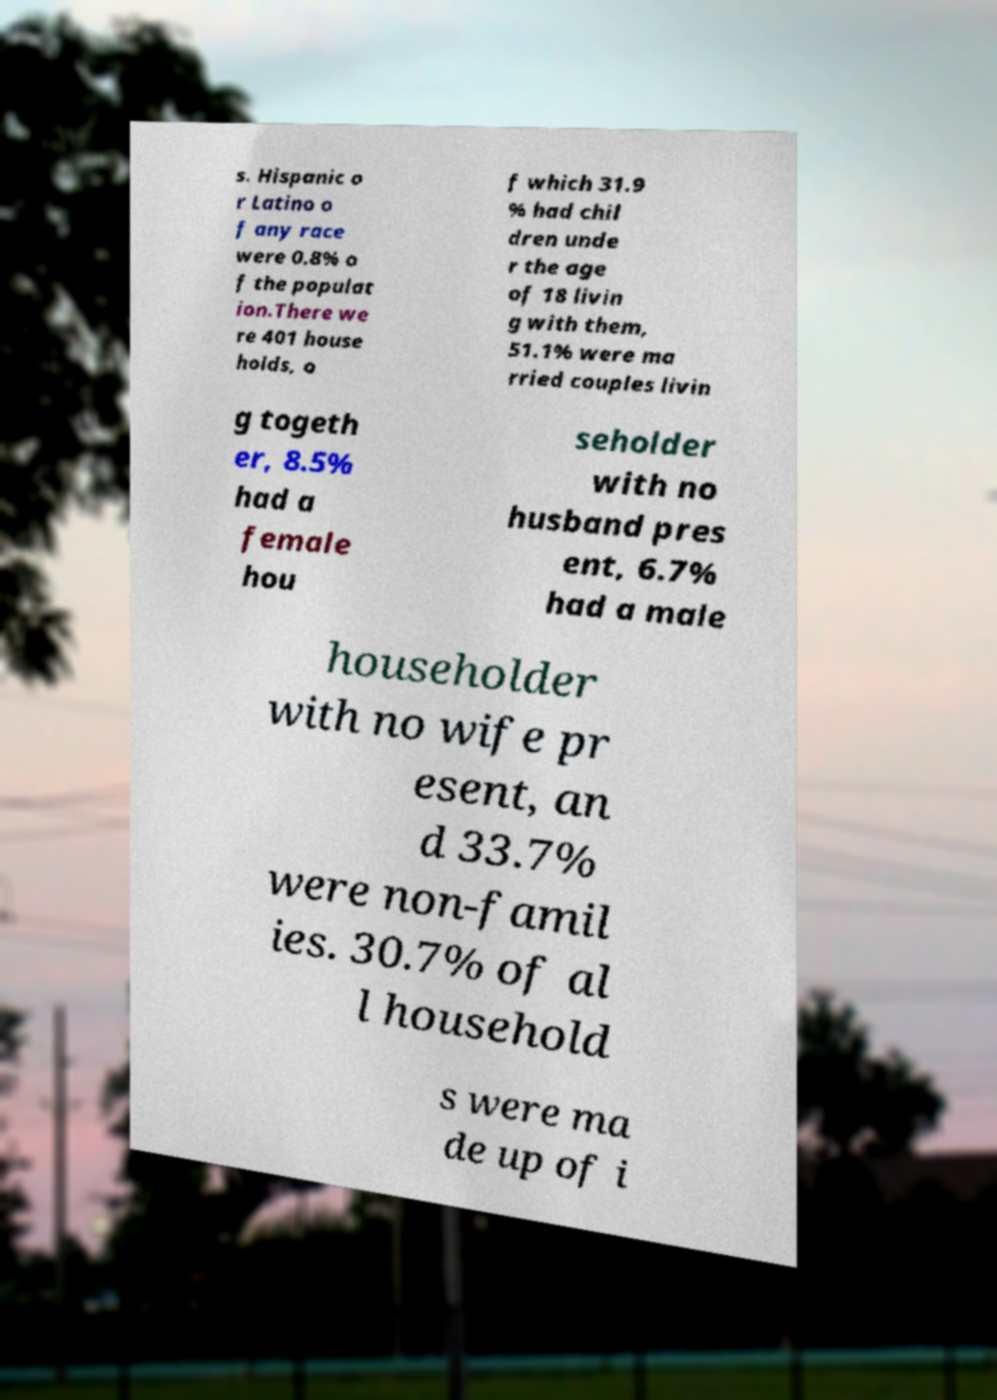What messages or text are displayed in this image? I need them in a readable, typed format. s. Hispanic o r Latino o f any race were 0.8% o f the populat ion.There we re 401 house holds, o f which 31.9 % had chil dren unde r the age of 18 livin g with them, 51.1% were ma rried couples livin g togeth er, 8.5% had a female hou seholder with no husband pres ent, 6.7% had a male householder with no wife pr esent, an d 33.7% were non-famil ies. 30.7% of al l household s were ma de up of i 